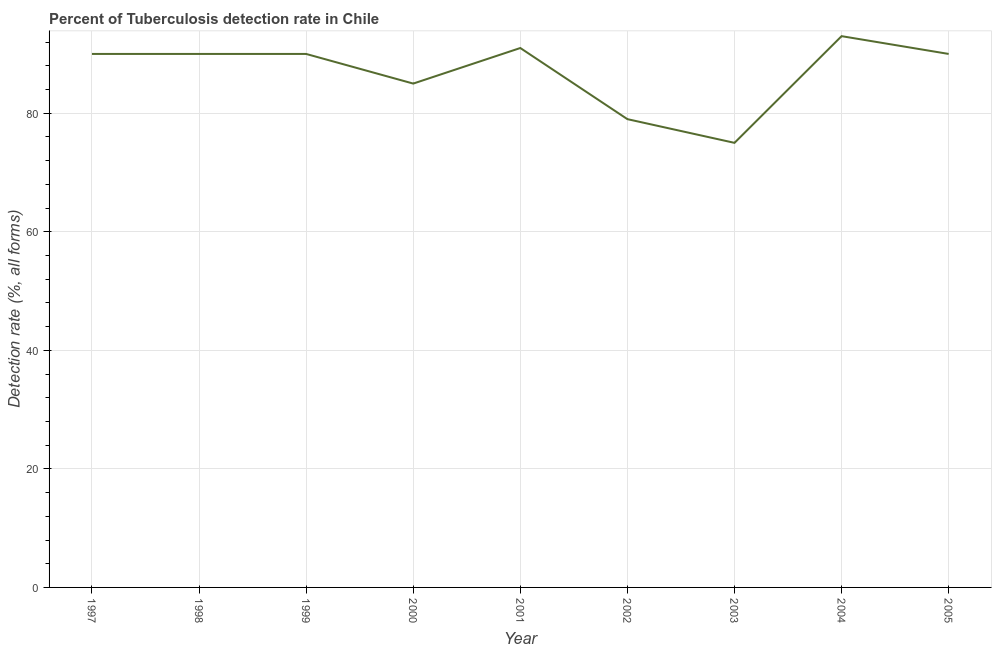What is the detection rate of tuberculosis in 2001?
Ensure brevity in your answer.  91. Across all years, what is the maximum detection rate of tuberculosis?
Give a very brief answer. 93. Across all years, what is the minimum detection rate of tuberculosis?
Keep it short and to the point. 75. In which year was the detection rate of tuberculosis maximum?
Your answer should be very brief. 2004. What is the sum of the detection rate of tuberculosis?
Provide a short and direct response. 783. What is the difference between the detection rate of tuberculosis in 2000 and 2004?
Your answer should be compact. -8. What is the average detection rate of tuberculosis per year?
Provide a short and direct response. 87. In how many years, is the detection rate of tuberculosis greater than 16 %?
Offer a very short reply. 9. Do a majority of the years between 2003 and 1997 (inclusive) have detection rate of tuberculosis greater than 8 %?
Offer a very short reply. Yes. What is the ratio of the detection rate of tuberculosis in 1997 to that in 2002?
Provide a succinct answer. 1.14. Is the difference between the detection rate of tuberculosis in 2000 and 2003 greater than the difference between any two years?
Keep it short and to the point. No. What is the difference between the highest and the lowest detection rate of tuberculosis?
Offer a terse response. 18. In how many years, is the detection rate of tuberculosis greater than the average detection rate of tuberculosis taken over all years?
Offer a terse response. 6. Does the detection rate of tuberculosis monotonically increase over the years?
Make the answer very short. No. How many years are there in the graph?
Keep it short and to the point. 9. What is the title of the graph?
Provide a short and direct response. Percent of Tuberculosis detection rate in Chile. What is the label or title of the X-axis?
Make the answer very short. Year. What is the label or title of the Y-axis?
Your answer should be very brief. Detection rate (%, all forms). What is the Detection rate (%, all forms) in 1997?
Make the answer very short. 90. What is the Detection rate (%, all forms) in 1999?
Offer a terse response. 90. What is the Detection rate (%, all forms) in 2000?
Keep it short and to the point. 85. What is the Detection rate (%, all forms) of 2001?
Your answer should be very brief. 91. What is the Detection rate (%, all forms) in 2002?
Ensure brevity in your answer.  79. What is the Detection rate (%, all forms) of 2004?
Your answer should be very brief. 93. What is the difference between the Detection rate (%, all forms) in 1997 and 1999?
Give a very brief answer. 0. What is the difference between the Detection rate (%, all forms) in 1997 and 2000?
Your response must be concise. 5. What is the difference between the Detection rate (%, all forms) in 1997 and 2001?
Your answer should be compact. -1. What is the difference between the Detection rate (%, all forms) in 1997 and 2002?
Provide a succinct answer. 11. What is the difference between the Detection rate (%, all forms) in 1997 and 2003?
Provide a short and direct response. 15. What is the difference between the Detection rate (%, all forms) in 1997 and 2004?
Ensure brevity in your answer.  -3. What is the difference between the Detection rate (%, all forms) in 1999 and 2001?
Offer a terse response. -1. What is the difference between the Detection rate (%, all forms) in 1999 and 2002?
Your answer should be very brief. 11. What is the difference between the Detection rate (%, all forms) in 2001 and 2002?
Your response must be concise. 12. What is the ratio of the Detection rate (%, all forms) in 1997 to that in 2000?
Offer a terse response. 1.06. What is the ratio of the Detection rate (%, all forms) in 1997 to that in 2001?
Your response must be concise. 0.99. What is the ratio of the Detection rate (%, all forms) in 1997 to that in 2002?
Provide a short and direct response. 1.14. What is the ratio of the Detection rate (%, all forms) in 1997 to that in 2003?
Ensure brevity in your answer.  1.2. What is the ratio of the Detection rate (%, all forms) in 1997 to that in 2004?
Give a very brief answer. 0.97. What is the ratio of the Detection rate (%, all forms) in 1998 to that in 1999?
Your answer should be very brief. 1. What is the ratio of the Detection rate (%, all forms) in 1998 to that in 2000?
Your answer should be compact. 1.06. What is the ratio of the Detection rate (%, all forms) in 1998 to that in 2001?
Your answer should be very brief. 0.99. What is the ratio of the Detection rate (%, all forms) in 1998 to that in 2002?
Your answer should be compact. 1.14. What is the ratio of the Detection rate (%, all forms) in 1998 to that in 2004?
Give a very brief answer. 0.97. What is the ratio of the Detection rate (%, all forms) in 1998 to that in 2005?
Provide a succinct answer. 1. What is the ratio of the Detection rate (%, all forms) in 1999 to that in 2000?
Your answer should be compact. 1.06. What is the ratio of the Detection rate (%, all forms) in 1999 to that in 2002?
Make the answer very short. 1.14. What is the ratio of the Detection rate (%, all forms) in 1999 to that in 2004?
Keep it short and to the point. 0.97. What is the ratio of the Detection rate (%, all forms) in 2000 to that in 2001?
Make the answer very short. 0.93. What is the ratio of the Detection rate (%, all forms) in 2000 to that in 2002?
Provide a short and direct response. 1.08. What is the ratio of the Detection rate (%, all forms) in 2000 to that in 2003?
Your answer should be compact. 1.13. What is the ratio of the Detection rate (%, all forms) in 2000 to that in 2004?
Your response must be concise. 0.91. What is the ratio of the Detection rate (%, all forms) in 2000 to that in 2005?
Your answer should be compact. 0.94. What is the ratio of the Detection rate (%, all forms) in 2001 to that in 2002?
Provide a succinct answer. 1.15. What is the ratio of the Detection rate (%, all forms) in 2001 to that in 2003?
Offer a terse response. 1.21. What is the ratio of the Detection rate (%, all forms) in 2001 to that in 2005?
Give a very brief answer. 1.01. What is the ratio of the Detection rate (%, all forms) in 2002 to that in 2003?
Keep it short and to the point. 1.05. What is the ratio of the Detection rate (%, all forms) in 2002 to that in 2004?
Your answer should be very brief. 0.85. What is the ratio of the Detection rate (%, all forms) in 2002 to that in 2005?
Your answer should be compact. 0.88. What is the ratio of the Detection rate (%, all forms) in 2003 to that in 2004?
Provide a short and direct response. 0.81. What is the ratio of the Detection rate (%, all forms) in 2003 to that in 2005?
Provide a short and direct response. 0.83. What is the ratio of the Detection rate (%, all forms) in 2004 to that in 2005?
Offer a terse response. 1.03. 